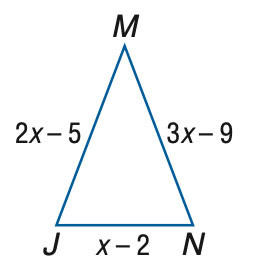Answer the mathemtical geometry problem and directly provide the correct option letter.
Question: Find J N if \triangle J M N is an isosceles triangle with J M \cong M N.
Choices: A: 2 B: 3 C: 4 D: 5 A 